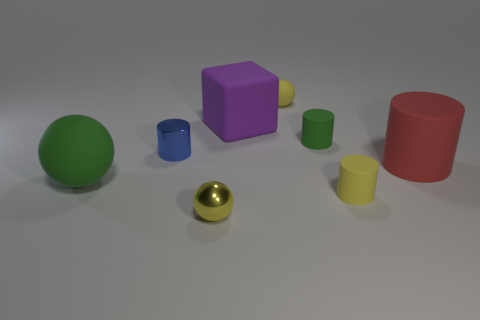Subtract all red balls. Subtract all red cylinders. How many balls are left? 3 Add 2 purple blocks. How many objects exist? 10 Subtract all cubes. How many objects are left? 7 Subtract all big cyan rubber cylinders. Subtract all tiny objects. How many objects are left? 3 Add 6 green matte spheres. How many green matte spheres are left? 7 Add 6 gray blocks. How many gray blocks exist? 6 Subtract 0 brown blocks. How many objects are left? 8 